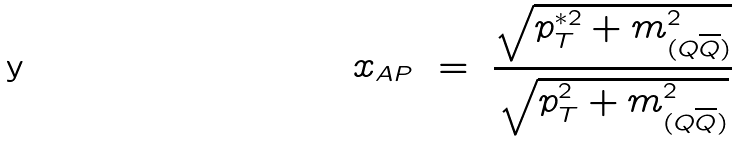Convert formula to latex. <formula><loc_0><loc_0><loc_500><loc_500>x _ { A P } \ = \ \frac { \sqrt { p _ { T } ^ { { \ast } 2 } + m _ { ( Q \overline { Q } ) } ^ { 2 } } } { \sqrt { p _ { T } ^ { 2 } + m _ { ( Q \overline { Q } ) } ^ { 2 } } }</formula> 